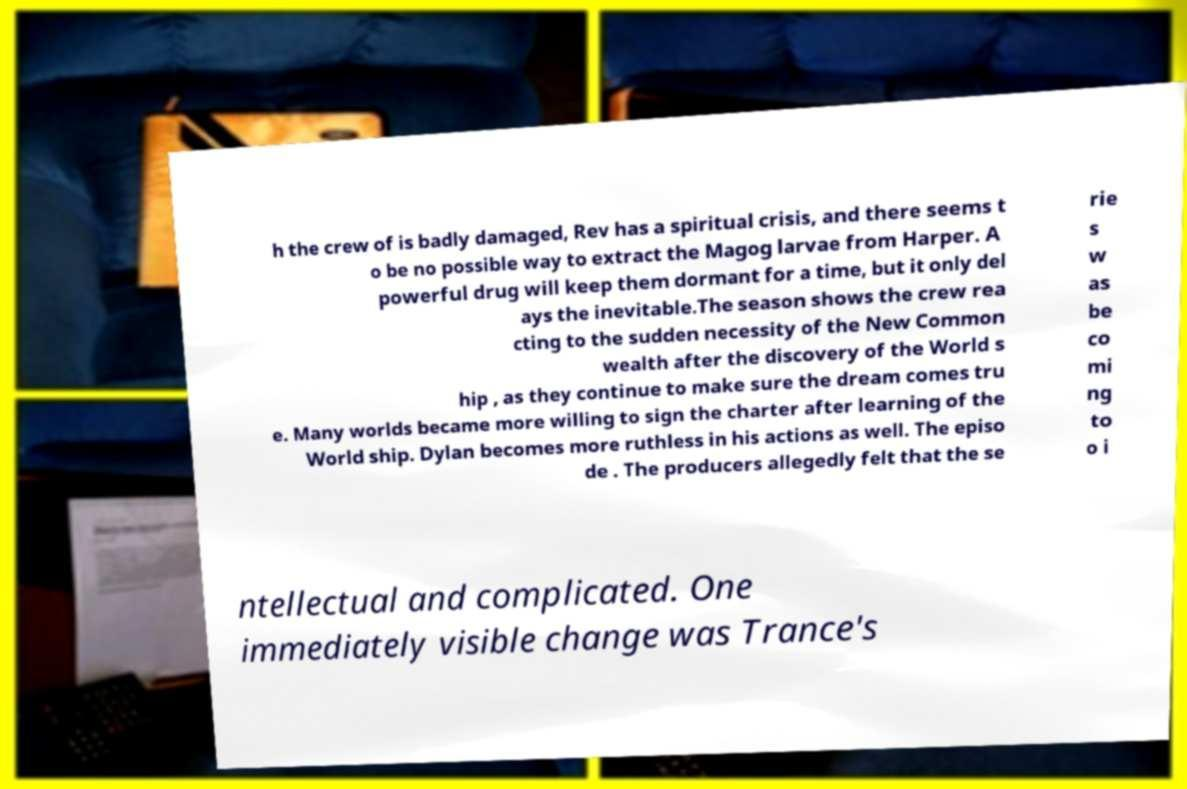Please read and relay the text visible in this image. What does it say? h the crew of is badly damaged, Rev has a spiritual crisis, and there seems t o be no possible way to extract the Magog larvae from Harper. A powerful drug will keep them dormant for a time, but it only del ays the inevitable.The season shows the crew rea cting to the sudden necessity of the New Common wealth after the discovery of the World s hip , as they continue to make sure the dream comes tru e. Many worlds became more willing to sign the charter after learning of the World ship. Dylan becomes more ruthless in his actions as well. The episo de . The producers allegedly felt that the se rie s w as be co mi ng to o i ntellectual and complicated. One immediately visible change was Trance's 